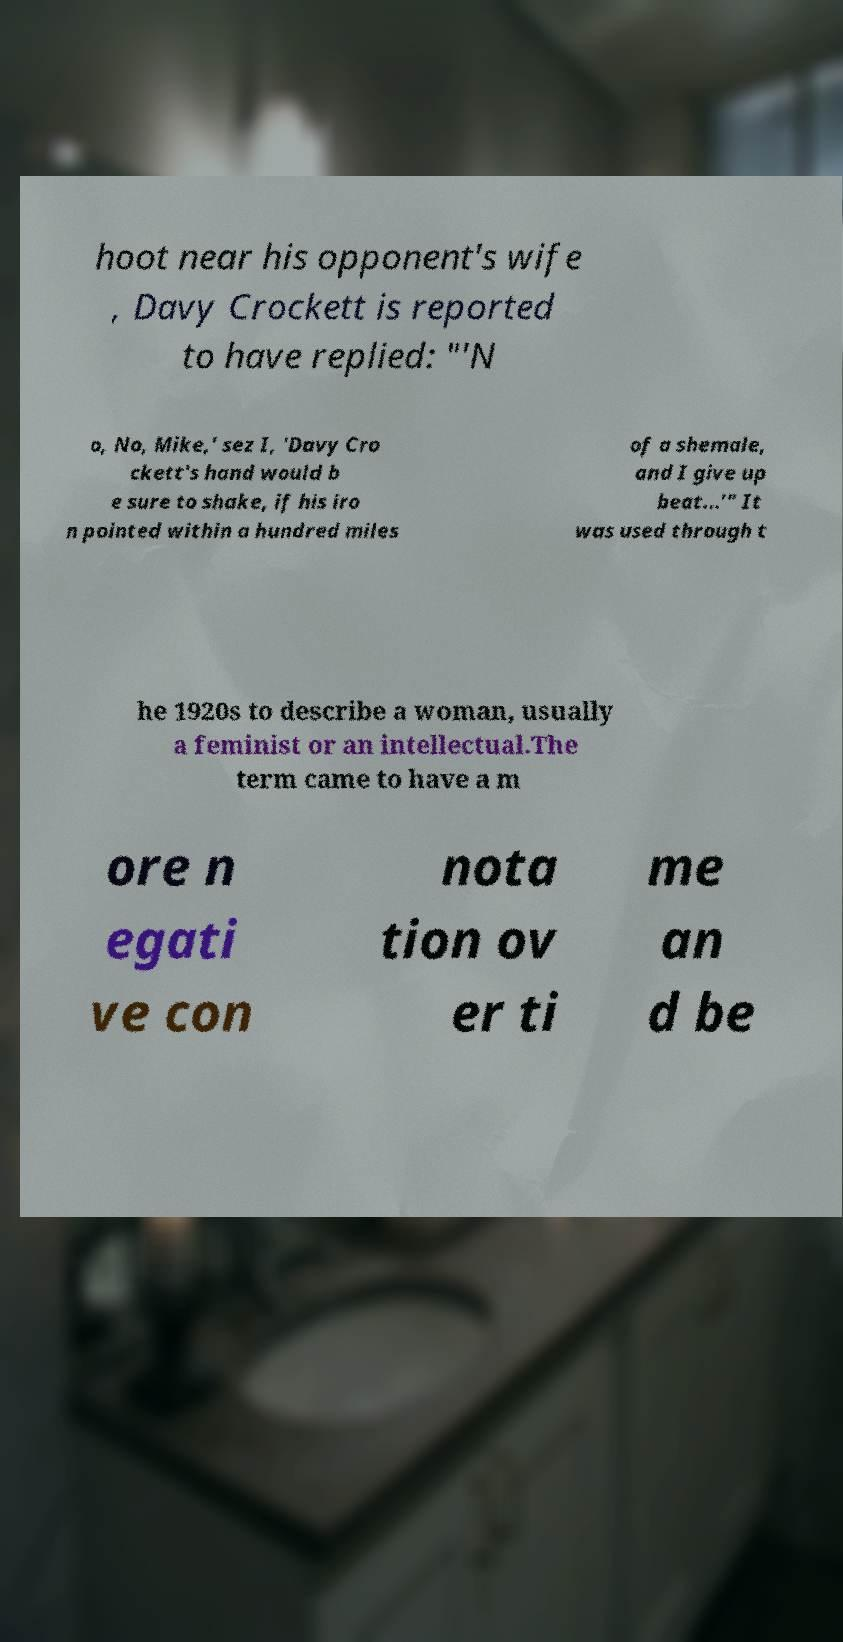What messages or text are displayed in this image? I need them in a readable, typed format. hoot near his opponent's wife , Davy Crockett is reported to have replied: "'N o, No, Mike,' sez I, 'Davy Cro ckett's hand would b e sure to shake, if his iro n pointed within a hundred miles of a shemale, and I give up beat...'" It was used through t he 1920s to describe a woman, usually a feminist or an intellectual.The term came to have a m ore n egati ve con nota tion ov er ti me an d be 